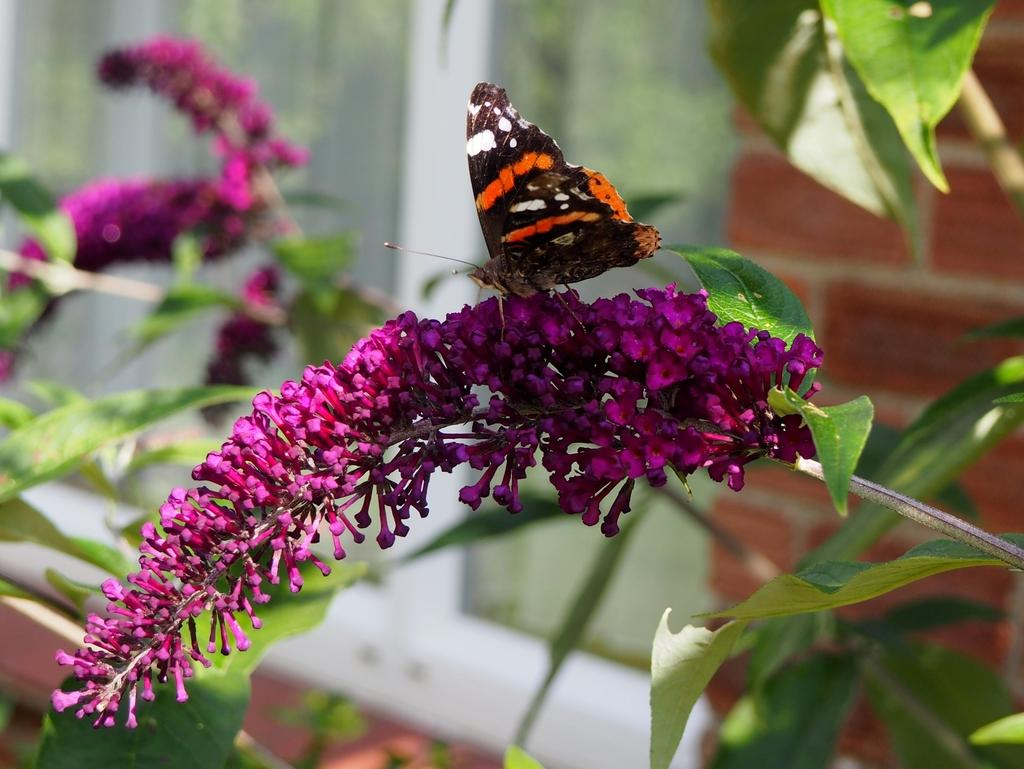What is the main subject of the image? There is a butterfly in the image. Where is the butterfly located? The butterfly is on a flower. Can you describe the colors of the butterfly? The butterfly has brown and orange colors. What color is the flower the butterfly is on? The flower has a pink color. What other elements can be seen in the image? There are leaves in the image. What color are the leaves? The leaves have a green color. Can you tell me how many muscles the kitty has in the image? There is no kitty present in the image, so it is not possible to determine the number of muscles it might have. 